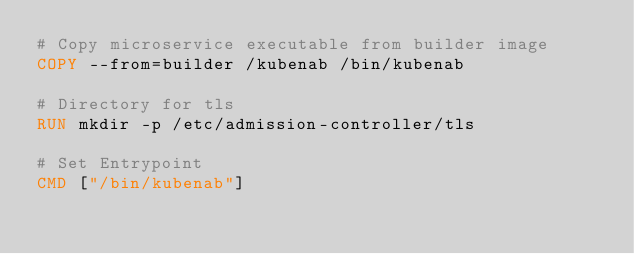<code> <loc_0><loc_0><loc_500><loc_500><_Dockerfile_># Copy microservice executable from builder image
COPY --from=builder /kubenab /bin/kubenab

# Directory for tls
RUN mkdir -p /etc/admission-controller/tls

# Set Entrypoint
CMD ["/bin/kubenab"]
</code> 